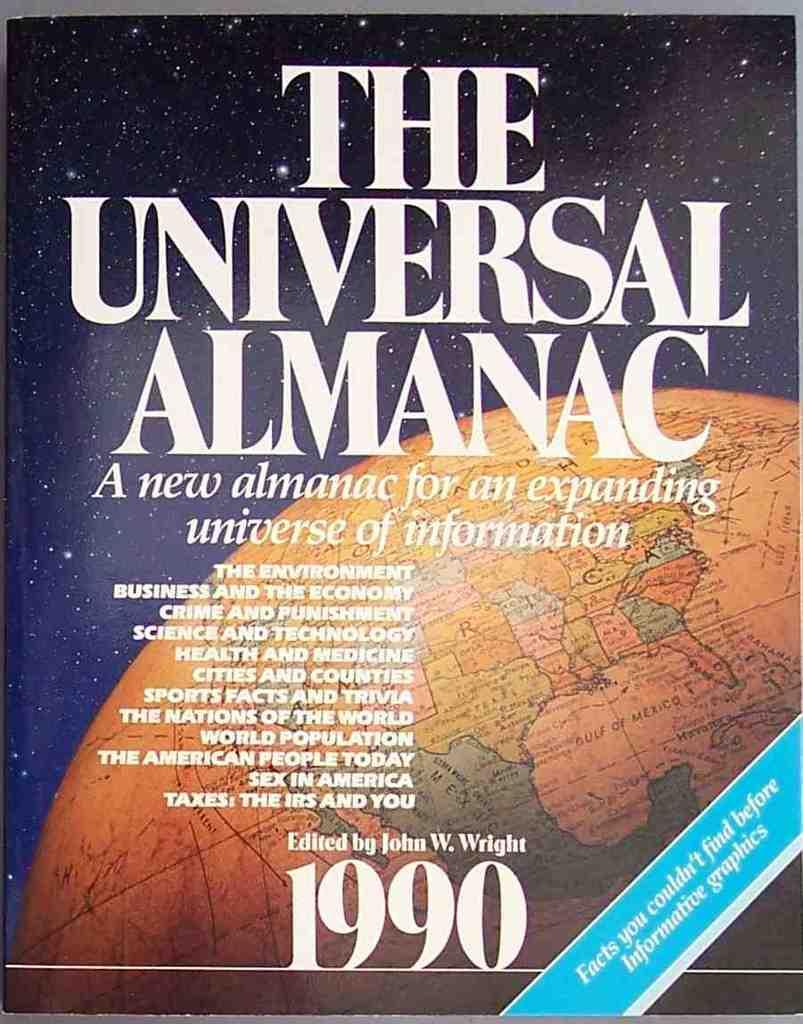<image>
Share a concise interpretation of the image provided. the cover of the universal almanac edited by john w wright. 